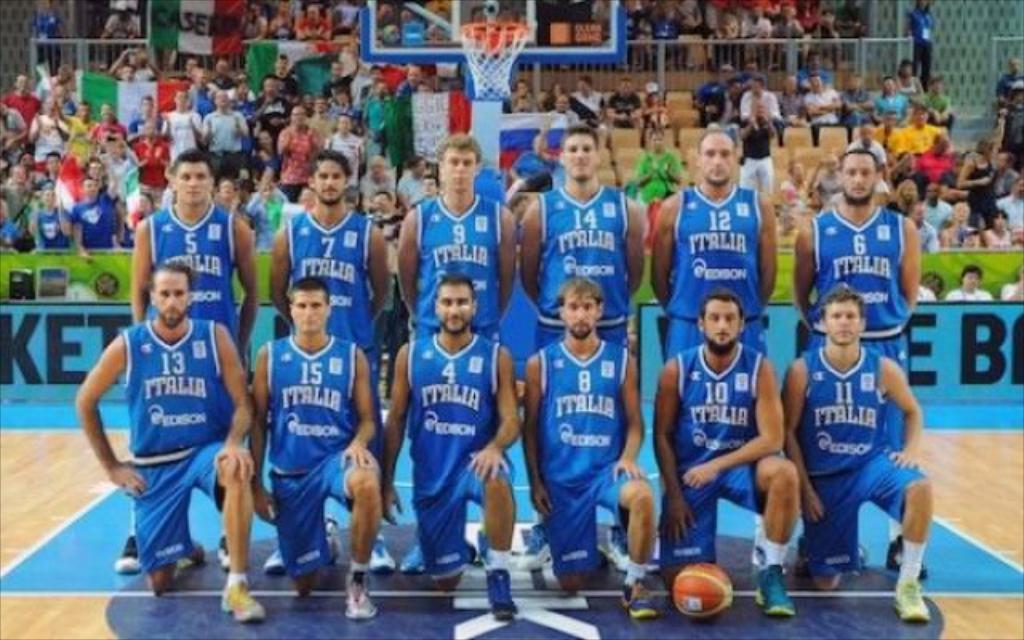Provide a one-sentence caption for the provided image. A men's basketball team poses for a picture after a game. 